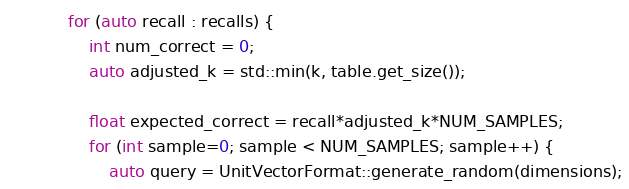<code> <loc_0><loc_0><loc_500><loc_500><_C++_>            for (auto recall : recalls) {
                int num_correct = 0;
                auto adjusted_k = std::min(k, table.get_size());
                
                float expected_correct = recall*adjusted_k*NUM_SAMPLES;
                for (int sample=0; sample < NUM_SAMPLES; sample++) {
                    auto query = UnitVectorFormat::generate_random(dimensions);</code> 